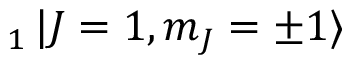Convert formula to latex. <formula><loc_0><loc_0><loc_500><loc_500>_ { 1 } \ m a t h i n n e r { | { J = 1 , m _ { J } = \pm 1 } \rangle }</formula> 